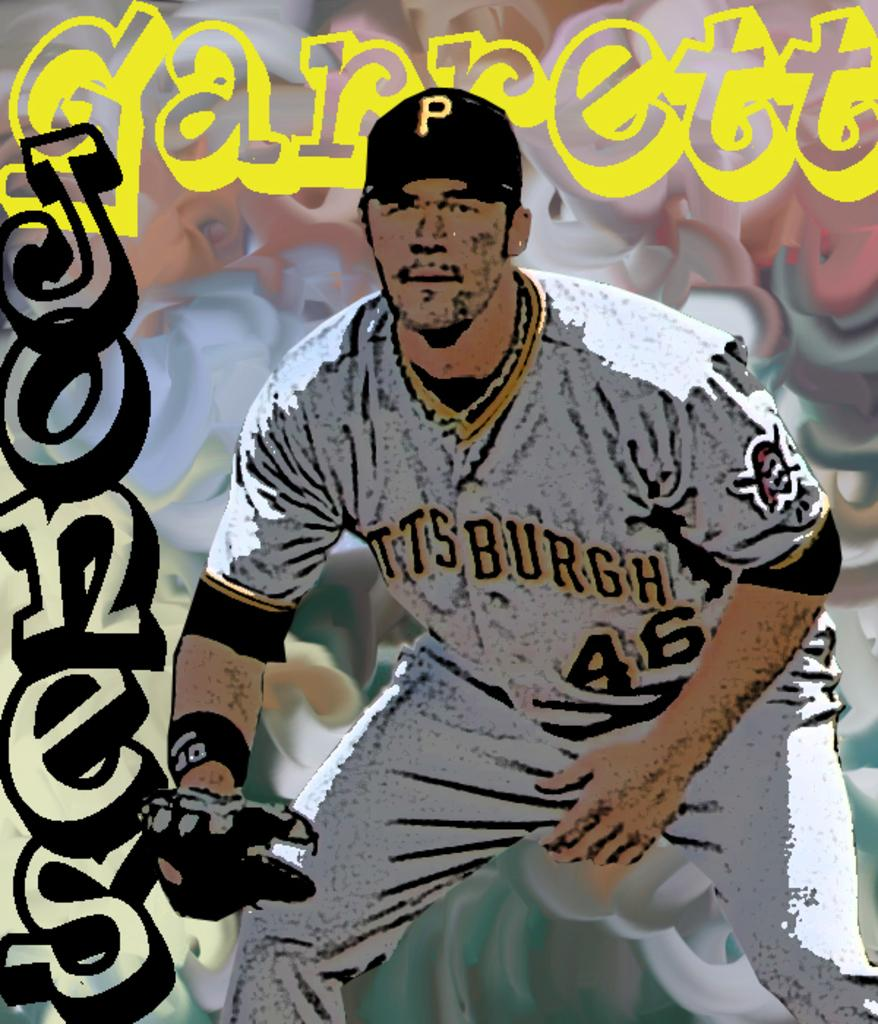<image>
Render a clear and concise summary of the photo. Player number 46 from Pittsburgh looking alert in order to catch the ball. 